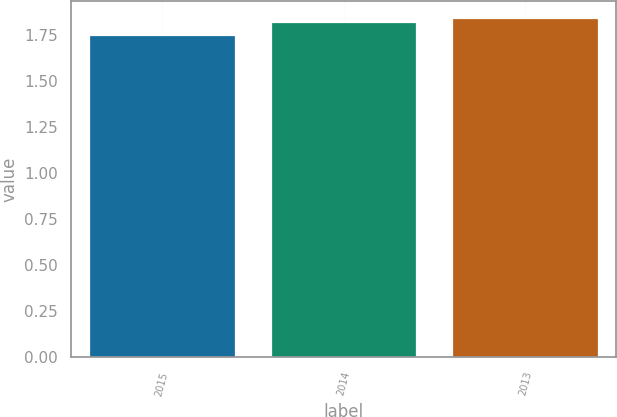Convert chart to OTSL. <chart><loc_0><loc_0><loc_500><loc_500><bar_chart><fcel>2015<fcel>2014<fcel>2013<nl><fcel>1.75<fcel>1.82<fcel>1.84<nl></chart> 